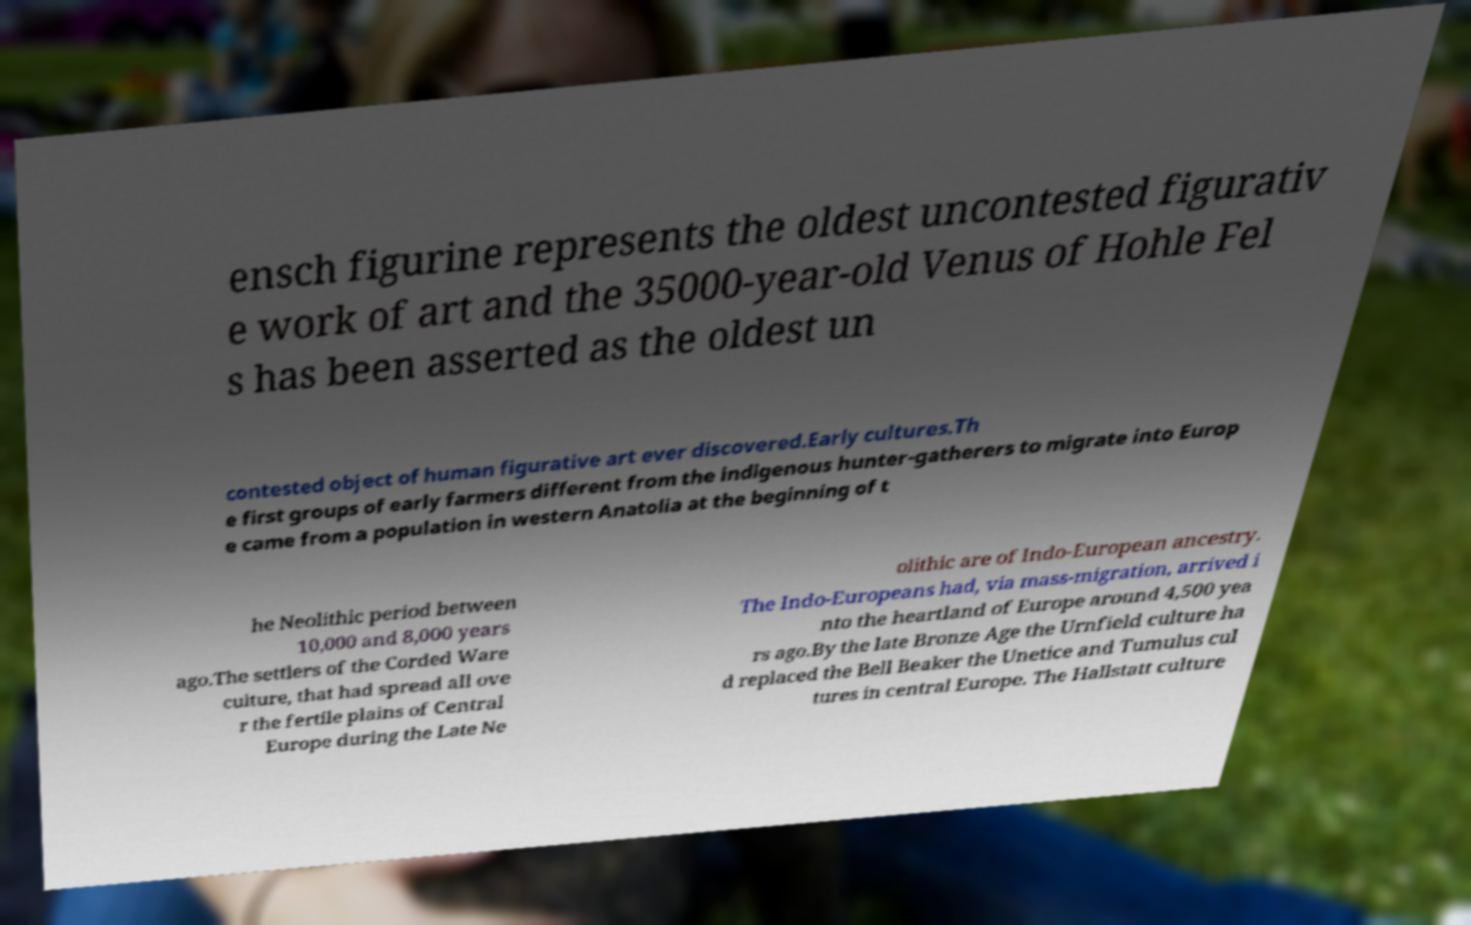What messages or text are displayed in this image? I need them in a readable, typed format. ensch figurine represents the oldest uncontested figurativ e work of art and the 35000-year-old Venus of Hohle Fel s has been asserted as the oldest un contested object of human figurative art ever discovered.Early cultures.Th e first groups of early farmers different from the indigenous hunter-gatherers to migrate into Europ e came from a population in western Anatolia at the beginning of t he Neolithic period between 10,000 and 8,000 years ago.The settlers of the Corded Ware culture, that had spread all ove r the fertile plains of Central Europe during the Late Ne olithic are of Indo-European ancestry. The Indo-Europeans had, via mass-migration, arrived i nto the heartland of Europe around 4,500 yea rs ago.By the late Bronze Age the Urnfield culture ha d replaced the Bell Beaker the Unetice and Tumulus cul tures in central Europe. The Hallstatt culture 